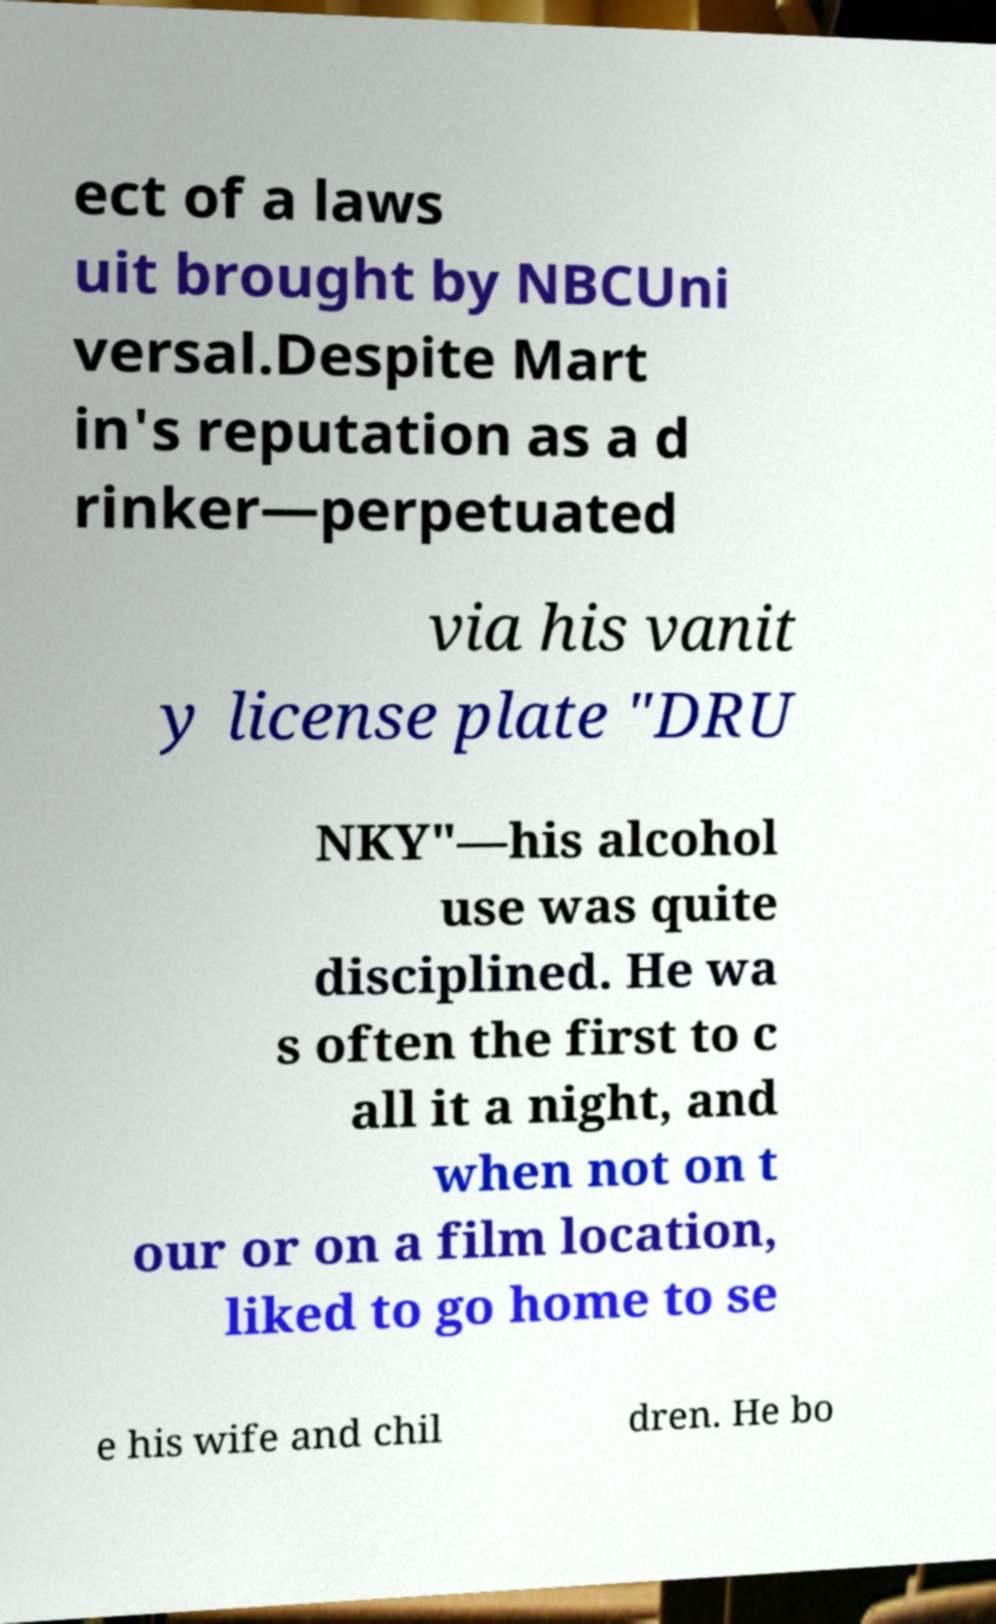Can you read and provide the text displayed in the image?This photo seems to have some interesting text. Can you extract and type it out for me? ect of a laws uit brought by NBCUni versal.Despite Mart in's reputation as a d rinker—perpetuated via his vanit y license plate "DRU NKY"—his alcohol use was quite disciplined. He wa s often the first to c all it a night, and when not on t our or on a film location, liked to go home to se e his wife and chil dren. He bo 